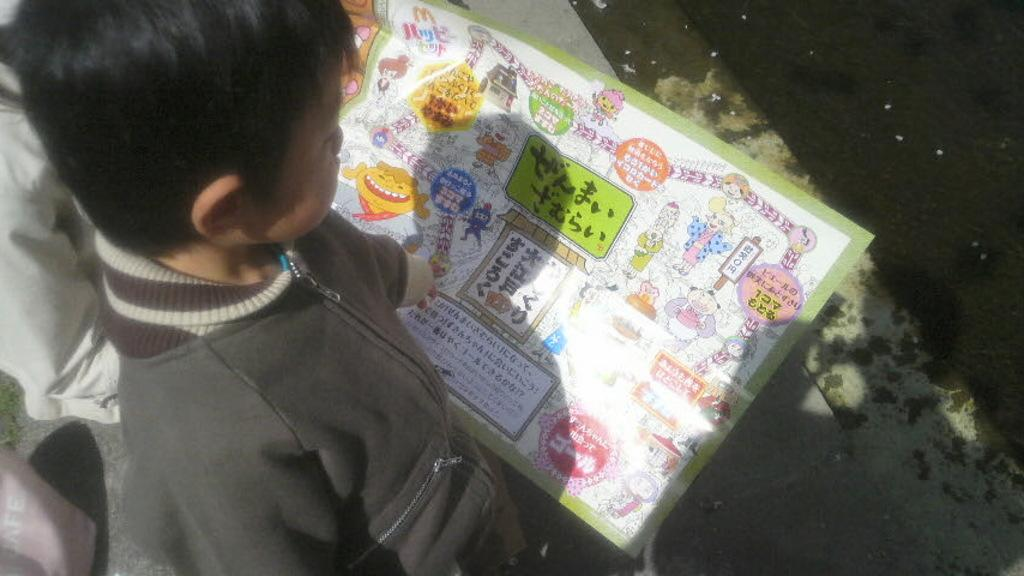What is the main subject in the foreground of the image? There is a boy in the foreground of the image. What is the boy wearing? The boy is wearing a jacket. What can be seen in the center of the image? There is a paper with text in the center of the image. What type of natural element is visible to the right side of the image? There is water visible to the right side of the image. How many women are present in the image? There is no mention of women in the provided facts, so we cannot determine the number of women present in the image. 